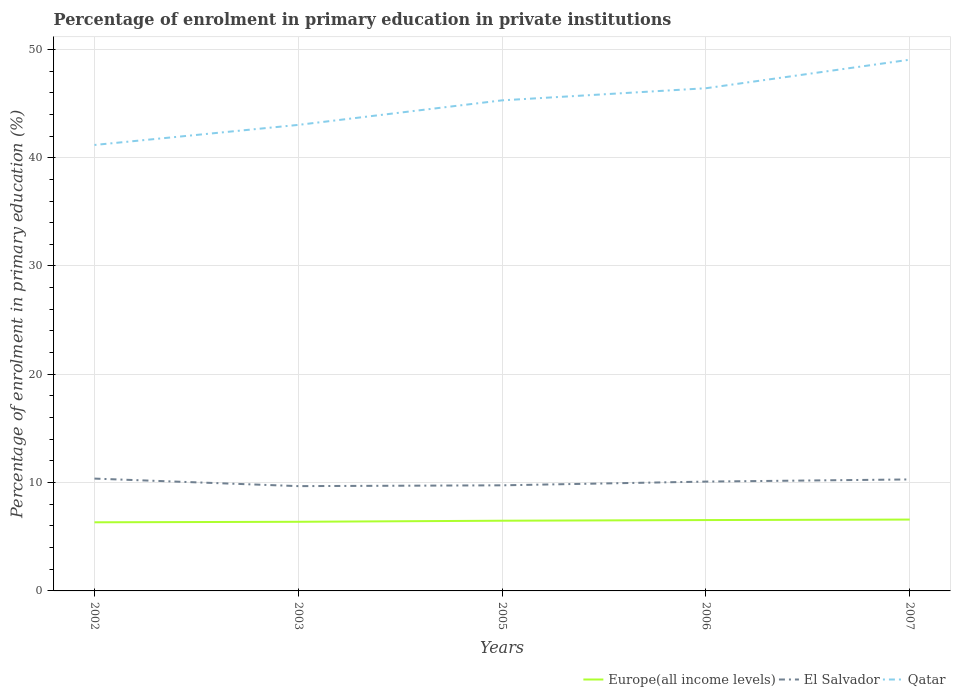Across all years, what is the maximum percentage of enrolment in primary education in Europe(all income levels)?
Offer a terse response. 6.34. In which year was the percentage of enrolment in primary education in El Salvador maximum?
Offer a terse response. 2003. What is the total percentage of enrolment in primary education in Europe(all income levels) in the graph?
Offer a terse response. -0.1. What is the difference between the highest and the second highest percentage of enrolment in primary education in Europe(all income levels)?
Your answer should be compact. 0.25. What is the difference between the highest and the lowest percentage of enrolment in primary education in El Salvador?
Your response must be concise. 3. How many years are there in the graph?
Provide a succinct answer. 5. Are the values on the major ticks of Y-axis written in scientific E-notation?
Provide a short and direct response. No. How many legend labels are there?
Provide a short and direct response. 3. What is the title of the graph?
Make the answer very short. Percentage of enrolment in primary education in private institutions. What is the label or title of the X-axis?
Your answer should be compact. Years. What is the label or title of the Y-axis?
Make the answer very short. Percentage of enrolment in primary education (%). What is the Percentage of enrolment in primary education (%) in Europe(all income levels) in 2002?
Your answer should be very brief. 6.34. What is the Percentage of enrolment in primary education (%) in El Salvador in 2002?
Your response must be concise. 10.37. What is the Percentage of enrolment in primary education (%) of Qatar in 2002?
Ensure brevity in your answer.  41.17. What is the Percentage of enrolment in primary education (%) of Europe(all income levels) in 2003?
Keep it short and to the point. 6.38. What is the Percentage of enrolment in primary education (%) in El Salvador in 2003?
Keep it short and to the point. 9.68. What is the Percentage of enrolment in primary education (%) in Qatar in 2003?
Your answer should be very brief. 43.03. What is the Percentage of enrolment in primary education (%) in Europe(all income levels) in 2005?
Offer a very short reply. 6.48. What is the Percentage of enrolment in primary education (%) of El Salvador in 2005?
Ensure brevity in your answer.  9.75. What is the Percentage of enrolment in primary education (%) in Qatar in 2005?
Ensure brevity in your answer.  45.29. What is the Percentage of enrolment in primary education (%) of Europe(all income levels) in 2006?
Your response must be concise. 6.54. What is the Percentage of enrolment in primary education (%) of El Salvador in 2006?
Provide a short and direct response. 10.09. What is the Percentage of enrolment in primary education (%) of Qatar in 2006?
Your answer should be very brief. 46.41. What is the Percentage of enrolment in primary education (%) of Europe(all income levels) in 2007?
Your response must be concise. 6.59. What is the Percentage of enrolment in primary education (%) in El Salvador in 2007?
Ensure brevity in your answer.  10.29. What is the Percentage of enrolment in primary education (%) of Qatar in 2007?
Your answer should be compact. 49.05. Across all years, what is the maximum Percentage of enrolment in primary education (%) of Europe(all income levels)?
Your response must be concise. 6.59. Across all years, what is the maximum Percentage of enrolment in primary education (%) of El Salvador?
Your answer should be compact. 10.37. Across all years, what is the maximum Percentage of enrolment in primary education (%) of Qatar?
Your answer should be compact. 49.05. Across all years, what is the minimum Percentage of enrolment in primary education (%) in Europe(all income levels)?
Make the answer very short. 6.34. Across all years, what is the minimum Percentage of enrolment in primary education (%) of El Salvador?
Offer a terse response. 9.68. Across all years, what is the minimum Percentage of enrolment in primary education (%) in Qatar?
Your answer should be very brief. 41.17. What is the total Percentage of enrolment in primary education (%) in Europe(all income levels) in the graph?
Your answer should be compact. 32.33. What is the total Percentage of enrolment in primary education (%) in El Salvador in the graph?
Your answer should be very brief. 50.19. What is the total Percentage of enrolment in primary education (%) of Qatar in the graph?
Keep it short and to the point. 224.95. What is the difference between the Percentage of enrolment in primary education (%) of Europe(all income levels) in 2002 and that in 2003?
Keep it short and to the point. -0.05. What is the difference between the Percentage of enrolment in primary education (%) of El Salvador in 2002 and that in 2003?
Provide a short and direct response. 0.7. What is the difference between the Percentage of enrolment in primary education (%) of Qatar in 2002 and that in 2003?
Your answer should be very brief. -1.85. What is the difference between the Percentage of enrolment in primary education (%) of Europe(all income levels) in 2002 and that in 2005?
Keep it short and to the point. -0.15. What is the difference between the Percentage of enrolment in primary education (%) of El Salvador in 2002 and that in 2005?
Your response must be concise. 0.62. What is the difference between the Percentage of enrolment in primary education (%) of Qatar in 2002 and that in 2005?
Your answer should be very brief. -4.12. What is the difference between the Percentage of enrolment in primary education (%) in Europe(all income levels) in 2002 and that in 2006?
Your response must be concise. -0.21. What is the difference between the Percentage of enrolment in primary education (%) of El Salvador in 2002 and that in 2006?
Offer a terse response. 0.28. What is the difference between the Percentage of enrolment in primary education (%) in Qatar in 2002 and that in 2006?
Your answer should be compact. -5.24. What is the difference between the Percentage of enrolment in primary education (%) in Europe(all income levels) in 2002 and that in 2007?
Your answer should be compact. -0.25. What is the difference between the Percentage of enrolment in primary education (%) in El Salvador in 2002 and that in 2007?
Offer a very short reply. 0.08. What is the difference between the Percentage of enrolment in primary education (%) of Qatar in 2002 and that in 2007?
Your answer should be compact. -7.87. What is the difference between the Percentage of enrolment in primary education (%) of Europe(all income levels) in 2003 and that in 2005?
Provide a succinct answer. -0.1. What is the difference between the Percentage of enrolment in primary education (%) of El Salvador in 2003 and that in 2005?
Your answer should be very brief. -0.07. What is the difference between the Percentage of enrolment in primary education (%) in Qatar in 2003 and that in 2005?
Offer a terse response. -2.27. What is the difference between the Percentage of enrolment in primary education (%) of Europe(all income levels) in 2003 and that in 2006?
Your answer should be very brief. -0.16. What is the difference between the Percentage of enrolment in primary education (%) of El Salvador in 2003 and that in 2006?
Your answer should be compact. -0.42. What is the difference between the Percentage of enrolment in primary education (%) in Qatar in 2003 and that in 2006?
Offer a terse response. -3.38. What is the difference between the Percentage of enrolment in primary education (%) in Europe(all income levels) in 2003 and that in 2007?
Your answer should be very brief. -0.2. What is the difference between the Percentage of enrolment in primary education (%) in El Salvador in 2003 and that in 2007?
Offer a very short reply. -0.62. What is the difference between the Percentage of enrolment in primary education (%) of Qatar in 2003 and that in 2007?
Keep it short and to the point. -6.02. What is the difference between the Percentage of enrolment in primary education (%) in Europe(all income levels) in 2005 and that in 2006?
Offer a very short reply. -0.06. What is the difference between the Percentage of enrolment in primary education (%) of El Salvador in 2005 and that in 2006?
Make the answer very short. -0.34. What is the difference between the Percentage of enrolment in primary education (%) of Qatar in 2005 and that in 2006?
Your answer should be compact. -1.12. What is the difference between the Percentage of enrolment in primary education (%) of Europe(all income levels) in 2005 and that in 2007?
Your answer should be compact. -0.11. What is the difference between the Percentage of enrolment in primary education (%) of El Salvador in 2005 and that in 2007?
Your answer should be compact. -0.54. What is the difference between the Percentage of enrolment in primary education (%) in Qatar in 2005 and that in 2007?
Your answer should be compact. -3.75. What is the difference between the Percentage of enrolment in primary education (%) of Europe(all income levels) in 2006 and that in 2007?
Ensure brevity in your answer.  -0.05. What is the difference between the Percentage of enrolment in primary education (%) of El Salvador in 2006 and that in 2007?
Your answer should be very brief. -0.2. What is the difference between the Percentage of enrolment in primary education (%) of Qatar in 2006 and that in 2007?
Your answer should be very brief. -2.63. What is the difference between the Percentage of enrolment in primary education (%) of Europe(all income levels) in 2002 and the Percentage of enrolment in primary education (%) of El Salvador in 2003?
Provide a short and direct response. -3.34. What is the difference between the Percentage of enrolment in primary education (%) in Europe(all income levels) in 2002 and the Percentage of enrolment in primary education (%) in Qatar in 2003?
Your answer should be compact. -36.69. What is the difference between the Percentage of enrolment in primary education (%) in El Salvador in 2002 and the Percentage of enrolment in primary education (%) in Qatar in 2003?
Make the answer very short. -32.66. What is the difference between the Percentage of enrolment in primary education (%) in Europe(all income levels) in 2002 and the Percentage of enrolment in primary education (%) in El Salvador in 2005?
Your response must be concise. -3.41. What is the difference between the Percentage of enrolment in primary education (%) in Europe(all income levels) in 2002 and the Percentage of enrolment in primary education (%) in Qatar in 2005?
Make the answer very short. -38.96. What is the difference between the Percentage of enrolment in primary education (%) of El Salvador in 2002 and the Percentage of enrolment in primary education (%) of Qatar in 2005?
Give a very brief answer. -34.92. What is the difference between the Percentage of enrolment in primary education (%) of Europe(all income levels) in 2002 and the Percentage of enrolment in primary education (%) of El Salvador in 2006?
Ensure brevity in your answer.  -3.76. What is the difference between the Percentage of enrolment in primary education (%) in Europe(all income levels) in 2002 and the Percentage of enrolment in primary education (%) in Qatar in 2006?
Offer a terse response. -40.08. What is the difference between the Percentage of enrolment in primary education (%) of El Salvador in 2002 and the Percentage of enrolment in primary education (%) of Qatar in 2006?
Offer a terse response. -36.04. What is the difference between the Percentage of enrolment in primary education (%) in Europe(all income levels) in 2002 and the Percentage of enrolment in primary education (%) in El Salvador in 2007?
Provide a succinct answer. -3.96. What is the difference between the Percentage of enrolment in primary education (%) of Europe(all income levels) in 2002 and the Percentage of enrolment in primary education (%) of Qatar in 2007?
Your answer should be compact. -42.71. What is the difference between the Percentage of enrolment in primary education (%) of El Salvador in 2002 and the Percentage of enrolment in primary education (%) of Qatar in 2007?
Provide a short and direct response. -38.68. What is the difference between the Percentage of enrolment in primary education (%) in Europe(all income levels) in 2003 and the Percentage of enrolment in primary education (%) in El Salvador in 2005?
Your answer should be very brief. -3.37. What is the difference between the Percentage of enrolment in primary education (%) in Europe(all income levels) in 2003 and the Percentage of enrolment in primary education (%) in Qatar in 2005?
Your response must be concise. -38.91. What is the difference between the Percentage of enrolment in primary education (%) in El Salvador in 2003 and the Percentage of enrolment in primary education (%) in Qatar in 2005?
Provide a short and direct response. -35.62. What is the difference between the Percentage of enrolment in primary education (%) in Europe(all income levels) in 2003 and the Percentage of enrolment in primary education (%) in El Salvador in 2006?
Keep it short and to the point. -3.71. What is the difference between the Percentage of enrolment in primary education (%) in Europe(all income levels) in 2003 and the Percentage of enrolment in primary education (%) in Qatar in 2006?
Offer a very short reply. -40.03. What is the difference between the Percentage of enrolment in primary education (%) of El Salvador in 2003 and the Percentage of enrolment in primary education (%) of Qatar in 2006?
Ensure brevity in your answer.  -36.74. What is the difference between the Percentage of enrolment in primary education (%) of Europe(all income levels) in 2003 and the Percentage of enrolment in primary education (%) of El Salvador in 2007?
Your answer should be compact. -3.91. What is the difference between the Percentage of enrolment in primary education (%) in Europe(all income levels) in 2003 and the Percentage of enrolment in primary education (%) in Qatar in 2007?
Your answer should be very brief. -42.66. What is the difference between the Percentage of enrolment in primary education (%) of El Salvador in 2003 and the Percentage of enrolment in primary education (%) of Qatar in 2007?
Make the answer very short. -39.37. What is the difference between the Percentage of enrolment in primary education (%) of Europe(all income levels) in 2005 and the Percentage of enrolment in primary education (%) of El Salvador in 2006?
Give a very brief answer. -3.61. What is the difference between the Percentage of enrolment in primary education (%) in Europe(all income levels) in 2005 and the Percentage of enrolment in primary education (%) in Qatar in 2006?
Your response must be concise. -39.93. What is the difference between the Percentage of enrolment in primary education (%) in El Salvador in 2005 and the Percentage of enrolment in primary education (%) in Qatar in 2006?
Make the answer very short. -36.66. What is the difference between the Percentage of enrolment in primary education (%) of Europe(all income levels) in 2005 and the Percentage of enrolment in primary education (%) of El Salvador in 2007?
Provide a short and direct response. -3.81. What is the difference between the Percentage of enrolment in primary education (%) of Europe(all income levels) in 2005 and the Percentage of enrolment in primary education (%) of Qatar in 2007?
Ensure brevity in your answer.  -42.56. What is the difference between the Percentage of enrolment in primary education (%) in El Salvador in 2005 and the Percentage of enrolment in primary education (%) in Qatar in 2007?
Your answer should be very brief. -39.3. What is the difference between the Percentage of enrolment in primary education (%) in Europe(all income levels) in 2006 and the Percentage of enrolment in primary education (%) in El Salvador in 2007?
Provide a short and direct response. -3.75. What is the difference between the Percentage of enrolment in primary education (%) in Europe(all income levels) in 2006 and the Percentage of enrolment in primary education (%) in Qatar in 2007?
Ensure brevity in your answer.  -42.5. What is the difference between the Percentage of enrolment in primary education (%) in El Salvador in 2006 and the Percentage of enrolment in primary education (%) in Qatar in 2007?
Make the answer very short. -38.95. What is the average Percentage of enrolment in primary education (%) in Europe(all income levels) per year?
Provide a short and direct response. 6.47. What is the average Percentage of enrolment in primary education (%) of El Salvador per year?
Your answer should be very brief. 10.04. What is the average Percentage of enrolment in primary education (%) of Qatar per year?
Offer a very short reply. 44.99. In the year 2002, what is the difference between the Percentage of enrolment in primary education (%) in Europe(all income levels) and Percentage of enrolment in primary education (%) in El Salvador?
Provide a short and direct response. -4.03. In the year 2002, what is the difference between the Percentage of enrolment in primary education (%) in Europe(all income levels) and Percentage of enrolment in primary education (%) in Qatar?
Keep it short and to the point. -34.84. In the year 2002, what is the difference between the Percentage of enrolment in primary education (%) of El Salvador and Percentage of enrolment in primary education (%) of Qatar?
Ensure brevity in your answer.  -30.8. In the year 2003, what is the difference between the Percentage of enrolment in primary education (%) of Europe(all income levels) and Percentage of enrolment in primary education (%) of El Salvador?
Provide a short and direct response. -3.29. In the year 2003, what is the difference between the Percentage of enrolment in primary education (%) in Europe(all income levels) and Percentage of enrolment in primary education (%) in Qatar?
Offer a terse response. -36.64. In the year 2003, what is the difference between the Percentage of enrolment in primary education (%) of El Salvador and Percentage of enrolment in primary education (%) of Qatar?
Keep it short and to the point. -33.35. In the year 2005, what is the difference between the Percentage of enrolment in primary education (%) in Europe(all income levels) and Percentage of enrolment in primary education (%) in El Salvador?
Provide a succinct answer. -3.27. In the year 2005, what is the difference between the Percentage of enrolment in primary education (%) of Europe(all income levels) and Percentage of enrolment in primary education (%) of Qatar?
Your response must be concise. -38.81. In the year 2005, what is the difference between the Percentage of enrolment in primary education (%) in El Salvador and Percentage of enrolment in primary education (%) in Qatar?
Your answer should be very brief. -35.54. In the year 2006, what is the difference between the Percentage of enrolment in primary education (%) of Europe(all income levels) and Percentage of enrolment in primary education (%) of El Salvador?
Keep it short and to the point. -3.55. In the year 2006, what is the difference between the Percentage of enrolment in primary education (%) in Europe(all income levels) and Percentage of enrolment in primary education (%) in Qatar?
Provide a succinct answer. -39.87. In the year 2006, what is the difference between the Percentage of enrolment in primary education (%) in El Salvador and Percentage of enrolment in primary education (%) in Qatar?
Provide a short and direct response. -36.32. In the year 2007, what is the difference between the Percentage of enrolment in primary education (%) in Europe(all income levels) and Percentage of enrolment in primary education (%) in El Salvador?
Give a very brief answer. -3.71. In the year 2007, what is the difference between the Percentage of enrolment in primary education (%) in Europe(all income levels) and Percentage of enrolment in primary education (%) in Qatar?
Give a very brief answer. -42.46. In the year 2007, what is the difference between the Percentage of enrolment in primary education (%) of El Salvador and Percentage of enrolment in primary education (%) of Qatar?
Give a very brief answer. -38.75. What is the ratio of the Percentage of enrolment in primary education (%) in Europe(all income levels) in 2002 to that in 2003?
Your answer should be compact. 0.99. What is the ratio of the Percentage of enrolment in primary education (%) of El Salvador in 2002 to that in 2003?
Your answer should be compact. 1.07. What is the ratio of the Percentage of enrolment in primary education (%) in Qatar in 2002 to that in 2003?
Ensure brevity in your answer.  0.96. What is the ratio of the Percentage of enrolment in primary education (%) in Europe(all income levels) in 2002 to that in 2005?
Keep it short and to the point. 0.98. What is the ratio of the Percentage of enrolment in primary education (%) in El Salvador in 2002 to that in 2005?
Keep it short and to the point. 1.06. What is the ratio of the Percentage of enrolment in primary education (%) in Qatar in 2002 to that in 2005?
Your response must be concise. 0.91. What is the ratio of the Percentage of enrolment in primary education (%) of Europe(all income levels) in 2002 to that in 2006?
Give a very brief answer. 0.97. What is the ratio of the Percentage of enrolment in primary education (%) in El Salvador in 2002 to that in 2006?
Your answer should be compact. 1.03. What is the ratio of the Percentage of enrolment in primary education (%) of Qatar in 2002 to that in 2006?
Keep it short and to the point. 0.89. What is the ratio of the Percentage of enrolment in primary education (%) in Europe(all income levels) in 2002 to that in 2007?
Keep it short and to the point. 0.96. What is the ratio of the Percentage of enrolment in primary education (%) of El Salvador in 2002 to that in 2007?
Keep it short and to the point. 1.01. What is the ratio of the Percentage of enrolment in primary education (%) in Qatar in 2002 to that in 2007?
Make the answer very short. 0.84. What is the ratio of the Percentage of enrolment in primary education (%) of Europe(all income levels) in 2003 to that in 2005?
Provide a short and direct response. 0.98. What is the ratio of the Percentage of enrolment in primary education (%) of Qatar in 2003 to that in 2005?
Provide a succinct answer. 0.95. What is the ratio of the Percentage of enrolment in primary education (%) of Europe(all income levels) in 2003 to that in 2006?
Offer a terse response. 0.98. What is the ratio of the Percentage of enrolment in primary education (%) of El Salvador in 2003 to that in 2006?
Provide a succinct answer. 0.96. What is the ratio of the Percentage of enrolment in primary education (%) in Qatar in 2003 to that in 2006?
Ensure brevity in your answer.  0.93. What is the ratio of the Percentage of enrolment in primary education (%) of Europe(all income levels) in 2003 to that in 2007?
Offer a terse response. 0.97. What is the ratio of the Percentage of enrolment in primary education (%) in El Salvador in 2003 to that in 2007?
Your answer should be compact. 0.94. What is the ratio of the Percentage of enrolment in primary education (%) of Qatar in 2003 to that in 2007?
Keep it short and to the point. 0.88. What is the ratio of the Percentage of enrolment in primary education (%) of Europe(all income levels) in 2005 to that in 2006?
Make the answer very short. 0.99. What is the ratio of the Percentage of enrolment in primary education (%) in El Salvador in 2005 to that in 2006?
Provide a short and direct response. 0.97. What is the ratio of the Percentage of enrolment in primary education (%) in Qatar in 2005 to that in 2006?
Your answer should be compact. 0.98. What is the ratio of the Percentage of enrolment in primary education (%) in Europe(all income levels) in 2005 to that in 2007?
Offer a terse response. 0.98. What is the ratio of the Percentage of enrolment in primary education (%) in El Salvador in 2005 to that in 2007?
Provide a short and direct response. 0.95. What is the ratio of the Percentage of enrolment in primary education (%) of Qatar in 2005 to that in 2007?
Provide a short and direct response. 0.92. What is the ratio of the Percentage of enrolment in primary education (%) in Europe(all income levels) in 2006 to that in 2007?
Provide a short and direct response. 0.99. What is the ratio of the Percentage of enrolment in primary education (%) in El Salvador in 2006 to that in 2007?
Offer a very short reply. 0.98. What is the ratio of the Percentage of enrolment in primary education (%) in Qatar in 2006 to that in 2007?
Your response must be concise. 0.95. What is the difference between the highest and the second highest Percentage of enrolment in primary education (%) of Europe(all income levels)?
Your response must be concise. 0.05. What is the difference between the highest and the second highest Percentage of enrolment in primary education (%) of El Salvador?
Make the answer very short. 0.08. What is the difference between the highest and the second highest Percentage of enrolment in primary education (%) of Qatar?
Offer a very short reply. 2.63. What is the difference between the highest and the lowest Percentage of enrolment in primary education (%) of Europe(all income levels)?
Provide a succinct answer. 0.25. What is the difference between the highest and the lowest Percentage of enrolment in primary education (%) of El Salvador?
Your response must be concise. 0.7. What is the difference between the highest and the lowest Percentage of enrolment in primary education (%) in Qatar?
Keep it short and to the point. 7.87. 